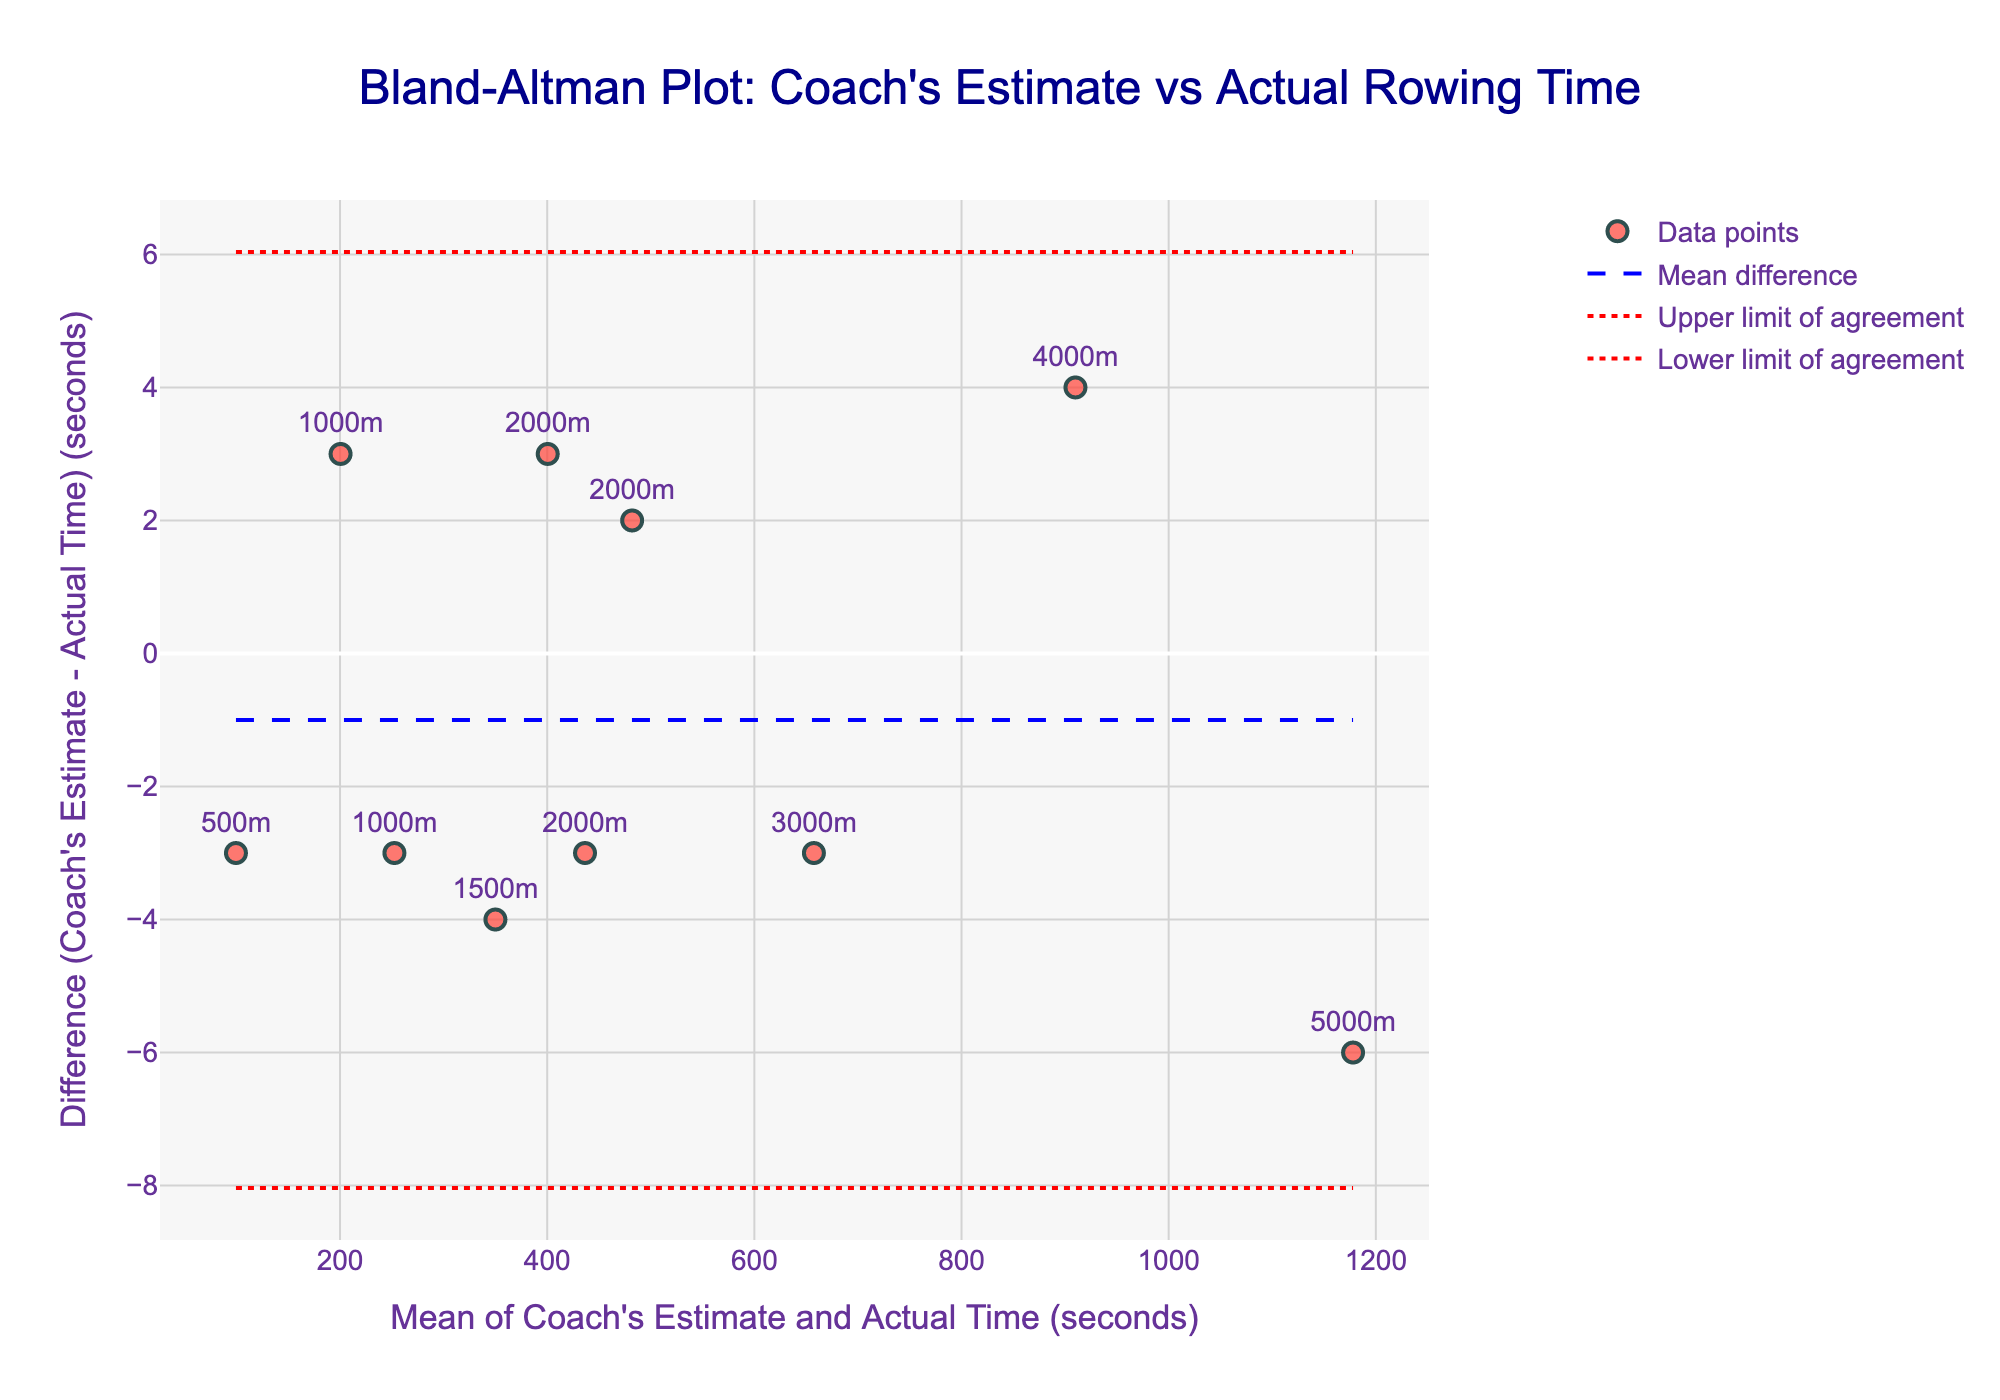What's the title of the figure? The title of a figure is usually located at the top and describes what the figure represents. In this case, it is "Bland-Altman Plot: Coach's Estimate vs Actual Rowing Time," which indicates that the plot compares coach's estimated rowing times with actual rowing times.
Answer: Bland-Altman Plot: Coach's Estimate vs Actual Rowing Time How many data points are plotted? The data points in the figure are marked by symbols. Since each data point is labeled with text indicating the distance, you can count the number of unique labels. There are 10 labels in total.
Answer: 10 What do the dots in the plot represent? The dots in the plot represent the differences between the coach's estimated time and the actual rowing time for each data point. Each dot is also labeled with the corresponding distance.
Answer: Differences for each distance What's the range of the x-axis? The x-axis in a Bland-Altman plot represents the mean between the coach's estimate and actual time. The range can be determined by looking at the minimum and maximum values on the x-axis. The plot spans from roughly 100 seconds to 1200 seconds.
Answer: 100 to 1200 seconds What is the mean difference line? The mean difference line in the Bland-Altman plot is indicated by a dashed blue line, which represents the average of the differences between the coach's estimates and the actual times.
Answer: Dashed blue line What's the upper limit of agreement? The upper limit of agreement is shown by the dotted red line at the higher position on the y-axis. This represents the mean difference plus 1.96 times the standard deviation. The exact value can be read off the plot.
Answer: Upper dotted red line What's the lower limit of agreement? The lower limit of agreement is shown by the dotted red line at the lower position on the y-axis. This represents the mean difference minus 1.96 times the standard deviation. The exact value can be read off the plot.
Answer: Lower dotted red line Which data point has the largest positive difference? The data point with the largest positive difference is marked by its vertical position in the plot. The highest point on the y-axis among the data points represents this. By identifying the highest point, it corresponds to the 5000m distance.
Answer: 5000m (Masato Yamamoto) Which distance has a negative difference? A negative difference is indicated by a data point below the horizontal zero line. Observing the plot, the 4000m (Shota Kimura) rower has a dot below this line.
Answer: 4000m (Shota Kimura) Which distance has the closest estimation by the coach compared to the actual time? The closest estimation will be represented by the data point closest to the zero line on the y-axis. Upon observing, the 2000m by Naoki Watanabe is closest to the zero line.
Answer: 2000m (Naoki Watanabe) 